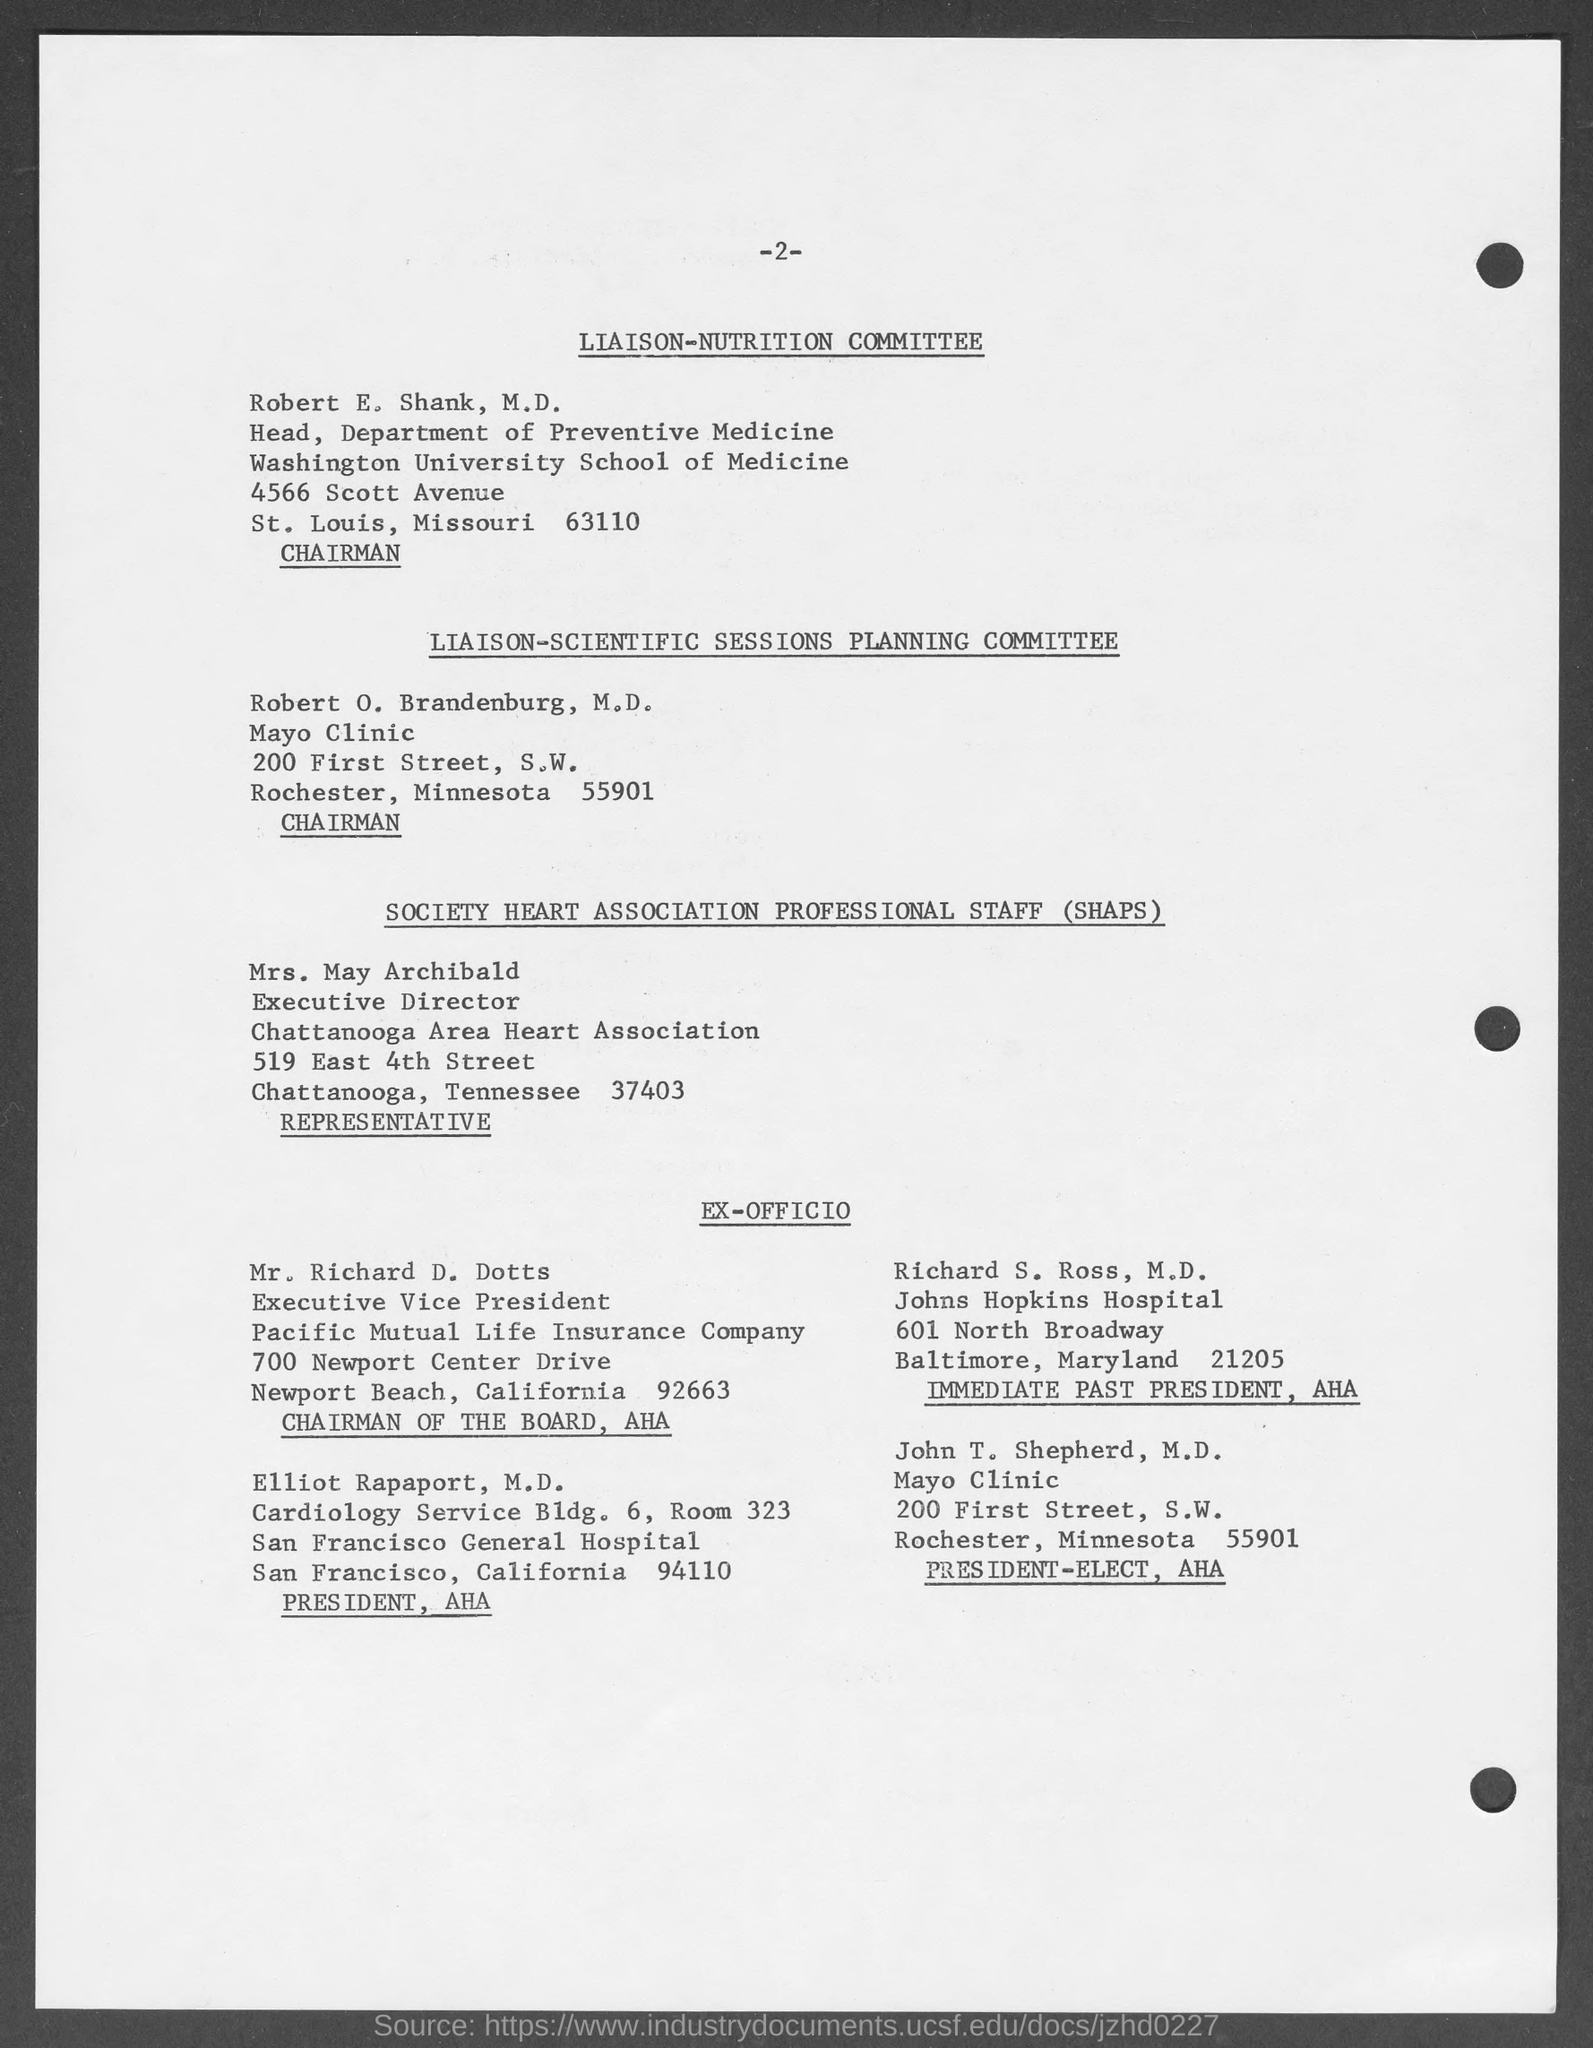What is the page no mentioned in this document?
Offer a terse response. 2. Who is the chairman of LIAISON-NUTRITION COMMITTEE?
Your response must be concise. Robert E. Shank, M.D. What is the designation of Robert E. Shank, M.D.?
Ensure brevity in your answer.  Head, Department of Preventive Medicine. Who is the Chairman of the Board, AHA?
Offer a terse response. Mr. richard d. dotts. What is the fullform of SHAPS?
Keep it short and to the point. SOCIETY HEART ASSOCIATION PROFESSIONAL STAFF. 